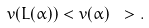<formula> <loc_0><loc_0><loc_500><loc_500>v ( L ( \alpha ) ) < v ( \alpha ) \ > .</formula> 